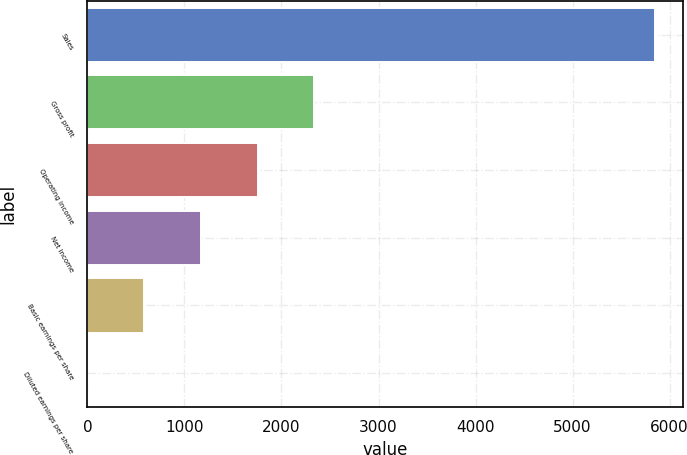<chart> <loc_0><loc_0><loc_500><loc_500><bar_chart><fcel>Sales<fcel>Gross profit<fcel>Operating income<fcel>Net income<fcel>Basic earnings per share<fcel>Diluted earnings per share<nl><fcel>5845<fcel>2338.12<fcel>1753.64<fcel>1169.16<fcel>584.68<fcel>0.2<nl></chart> 